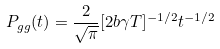Convert formula to latex. <formula><loc_0><loc_0><loc_500><loc_500>P _ { g g } ( t ) = \frac { 2 } { \sqrt { \pi } } [ 2 b \gamma T ] ^ { - 1 / 2 } t ^ { - 1 / 2 }</formula> 